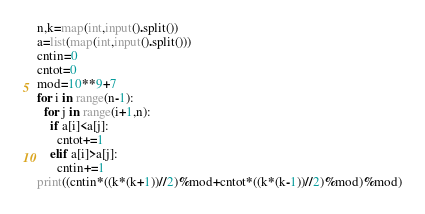<code> <loc_0><loc_0><loc_500><loc_500><_Python_>n,k=map(int,input().split())
a=list(map(int,input().split()))
cntin=0
cntot=0
mod=10**9+7
for i in range(n-1):
  for j in range(i+1,n):
    if a[i]<a[j]:
      cntot+=1
    elif a[i]>a[j]:
      cntin+=1
print((cntin*((k*(k+1))//2)%mod+cntot*((k*(k-1))//2)%mod)%mod)</code> 